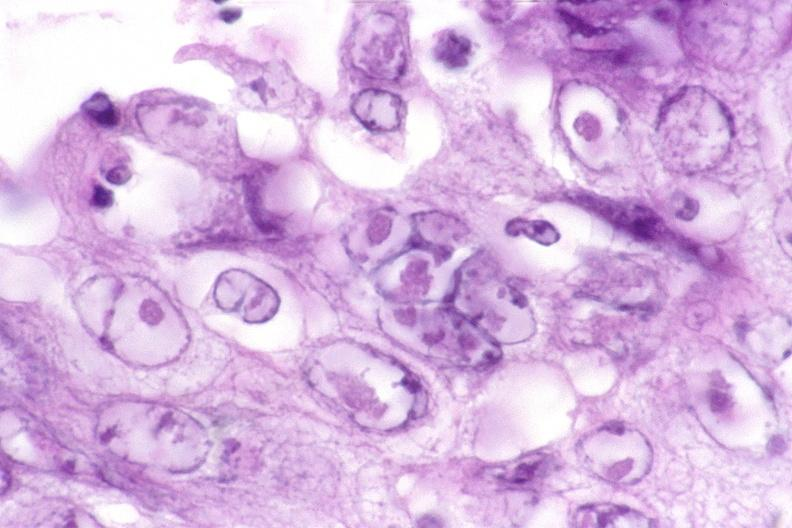s gastrointestinal present?
Answer the question using a single word or phrase. Yes 